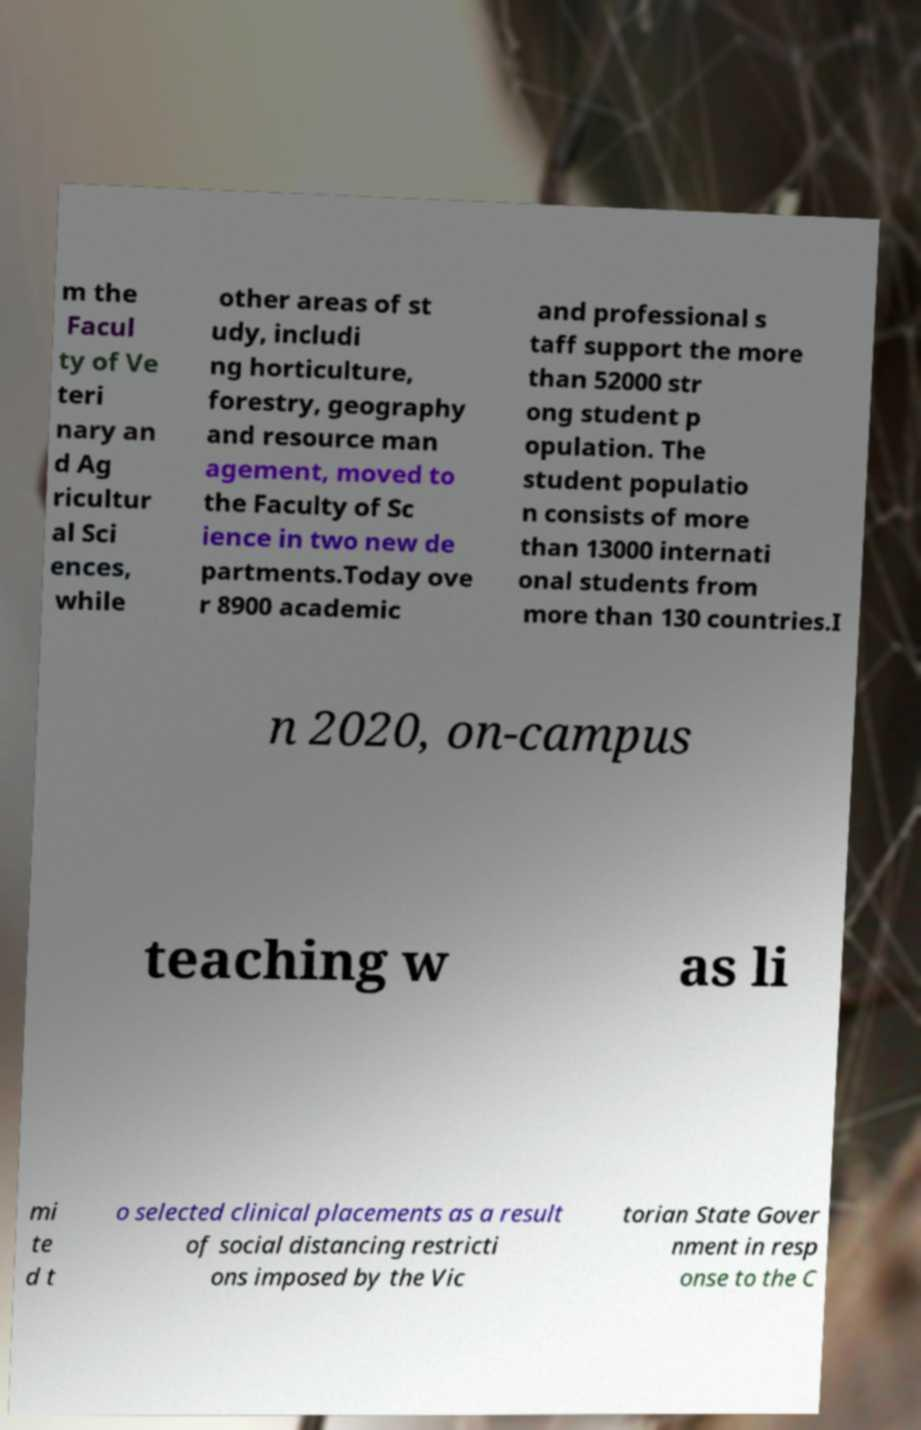Can you read and provide the text displayed in the image?This photo seems to have some interesting text. Can you extract and type it out for me? m the Facul ty of Ve teri nary an d Ag ricultur al Sci ences, while other areas of st udy, includi ng horticulture, forestry, geography and resource man agement, moved to the Faculty of Sc ience in two new de partments.Today ove r 8900 academic and professional s taff support the more than 52000 str ong student p opulation. The student populatio n consists of more than 13000 internati onal students from more than 130 countries.I n 2020, on-campus teaching w as li mi te d t o selected clinical placements as a result of social distancing restricti ons imposed by the Vic torian State Gover nment in resp onse to the C 